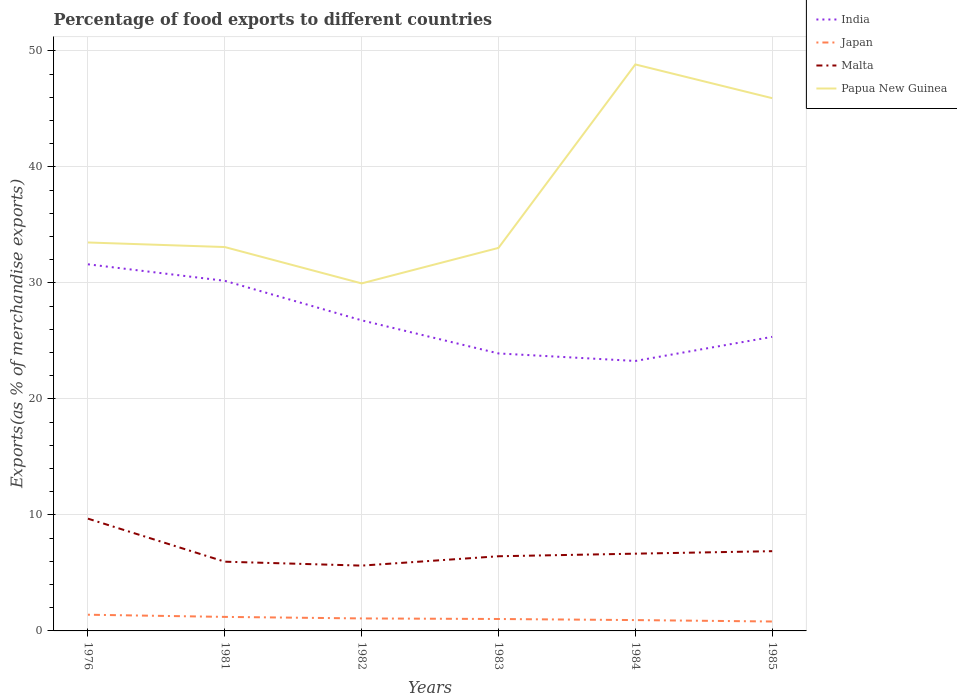How many different coloured lines are there?
Your response must be concise. 4. Is the number of lines equal to the number of legend labels?
Provide a succinct answer. Yes. Across all years, what is the maximum percentage of exports to different countries in India?
Give a very brief answer. 23.27. In which year was the percentage of exports to different countries in Malta maximum?
Keep it short and to the point. 1982. What is the total percentage of exports to different countries in Japan in the graph?
Provide a succinct answer. 0.4. What is the difference between the highest and the second highest percentage of exports to different countries in Japan?
Make the answer very short. 0.58. Does the graph contain any zero values?
Offer a very short reply. No. Does the graph contain grids?
Ensure brevity in your answer.  Yes. How are the legend labels stacked?
Provide a short and direct response. Vertical. What is the title of the graph?
Offer a terse response. Percentage of food exports to different countries. Does "France" appear as one of the legend labels in the graph?
Keep it short and to the point. No. What is the label or title of the X-axis?
Your response must be concise. Years. What is the label or title of the Y-axis?
Make the answer very short. Exports(as % of merchandise exports). What is the Exports(as % of merchandise exports) of India in 1976?
Your response must be concise. 31.6. What is the Exports(as % of merchandise exports) of Japan in 1976?
Your response must be concise. 1.4. What is the Exports(as % of merchandise exports) of Malta in 1976?
Offer a terse response. 9.68. What is the Exports(as % of merchandise exports) in Papua New Guinea in 1976?
Ensure brevity in your answer.  33.48. What is the Exports(as % of merchandise exports) in India in 1981?
Offer a terse response. 30.18. What is the Exports(as % of merchandise exports) of Japan in 1981?
Offer a terse response. 1.21. What is the Exports(as % of merchandise exports) in Malta in 1981?
Provide a short and direct response. 5.97. What is the Exports(as % of merchandise exports) in Papua New Guinea in 1981?
Your answer should be compact. 33.09. What is the Exports(as % of merchandise exports) in India in 1982?
Provide a succinct answer. 26.77. What is the Exports(as % of merchandise exports) in Japan in 1982?
Ensure brevity in your answer.  1.08. What is the Exports(as % of merchandise exports) in Malta in 1982?
Give a very brief answer. 5.63. What is the Exports(as % of merchandise exports) in Papua New Guinea in 1982?
Offer a terse response. 29.95. What is the Exports(as % of merchandise exports) in India in 1983?
Offer a very short reply. 23.92. What is the Exports(as % of merchandise exports) in Japan in 1983?
Provide a short and direct response. 1.03. What is the Exports(as % of merchandise exports) of Malta in 1983?
Provide a succinct answer. 6.44. What is the Exports(as % of merchandise exports) in Papua New Guinea in 1983?
Offer a terse response. 33.01. What is the Exports(as % of merchandise exports) of India in 1984?
Offer a terse response. 23.27. What is the Exports(as % of merchandise exports) of Japan in 1984?
Your response must be concise. 0.93. What is the Exports(as % of merchandise exports) in Malta in 1984?
Offer a very short reply. 6.66. What is the Exports(as % of merchandise exports) in Papua New Guinea in 1984?
Your response must be concise. 48.83. What is the Exports(as % of merchandise exports) of India in 1985?
Keep it short and to the point. 25.35. What is the Exports(as % of merchandise exports) of Japan in 1985?
Your answer should be very brief. 0.81. What is the Exports(as % of merchandise exports) of Malta in 1985?
Offer a terse response. 6.87. What is the Exports(as % of merchandise exports) in Papua New Guinea in 1985?
Ensure brevity in your answer.  45.92. Across all years, what is the maximum Exports(as % of merchandise exports) of India?
Give a very brief answer. 31.6. Across all years, what is the maximum Exports(as % of merchandise exports) in Japan?
Your answer should be compact. 1.4. Across all years, what is the maximum Exports(as % of merchandise exports) of Malta?
Your response must be concise. 9.68. Across all years, what is the maximum Exports(as % of merchandise exports) in Papua New Guinea?
Your answer should be very brief. 48.83. Across all years, what is the minimum Exports(as % of merchandise exports) of India?
Your answer should be very brief. 23.27. Across all years, what is the minimum Exports(as % of merchandise exports) in Japan?
Give a very brief answer. 0.81. Across all years, what is the minimum Exports(as % of merchandise exports) of Malta?
Keep it short and to the point. 5.63. Across all years, what is the minimum Exports(as % of merchandise exports) of Papua New Guinea?
Your response must be concise. 29.95. What is the total Exports(as % of merchandise exports) in India in the graph?
Make the answer very short. 161.08. What is the total Exports(as % of merchandise exports) of Japan in the graph?
Provide a succinct answer. 6.46. What is the total Exports(as % of merchandise exports) of Malta in the graph?
Keep it short and to the point. 41.24. What is the total Exports(as % of merchandise exports) in Papua New Guinea in the graph?
Provide a short and direct response. 224.28. What is the difference between the Exports(as % of merchandise exports) of India in 1976 and that in 1981?
Give a very brief answer. 1.42. What is the difference between the Exports(as % of merchandise exports) in Japan in 1976 and that in 1981?
Provide a short and direct response. 0.19. What is the difference between the Exports(as % of merchandise exports) in Malta in 1976 and that in 1981?
Ensure brevity in your answer.  3.71. What is the difference between the Exports(as % of merchandise exports) in Papua New Guinea in 1976 and that in 1981?
Provide a succinct answer. 0.39. What is the difference between the Exports(as % of merchandise exports) of India in 1976 and that in 1982?
Make the answer very short. 4.83. What is the difference between the Exports(as % of merchandise exports) in Japan in 1976 and that in 1982?
Your answer should be compact. 0.32. What is the difference between the Exports(as % of merchandise exports) of Malta in 1976 and that in 1982?
Make the answer very short. 4.05. What is the difference between the Exports(as % of merchandise exports) in Papua New Guinea in 1976 and that in 1982?
Provide a succinct answer. 3.53. What is the difference between the Exports(as % of merchandise exports) in India in 1976 and that in 1983?
Offer a very short reply. 7.68. What is the difference between the Exports(as % of merchandise exports) in Japan in 1976 and that in 1983?
Keep it short and to the point. 0.37. What is the difference between the Exports(as % of merchandise exports) in Malta in 1976 and that in 1983?
Your response must be concise. 3.24. What is the difference between the Exports(as % of merchandise exports) in Papua New Guinea in 1976 and that in 1983?
Offer a very short reply. 0.47. What is the difference between the Exports(as % of merchandise exports) of India in 1976 and that in 1984?
Your answer should be compact. 8.33. What is the difference between the Exports(as % of merchandise exports) in Japan in 1976 and that in 1984?
Keep it short and to the point. 0.46. What is the difference between the Exports(as % of merchandise exports) of Malta in 1976 and that in 1984?
Your response must be concise. 3.02. What is the difference between the Exports(as % of merchandise exports) in Papua New Guinea in 1976 and that in 1984?
Provide a short and direct response. -15.35. What is the difference between the Exports(as % of merchandise exports) of India in 1976 and that in 1985?
Offer a terse response. 6.25. What is the difference between the Exports(as % of merchandise exports) of Japan in 1976 and that in 1985?
Your answer should be compact. 0.58. What is the difference between the Exports(as % of merchandise exports) in Malta in 1976 and that in 1985?
Offer a very short reply. 2.8. What is the difference between the Exports(as % of merchandise exports) of Papua New Guinea in 1976 and that in 1985?
Your answer should be compact. -12.44. What is the difference between the Exports(as % of merchandise exports) of India in 1981 and that in 1982?
Ensure brevity in your answer.  3.41. What is the difference between the Exports(as % of merchandise exports) in Japan in 1981 and that in 1982?
Provide a succinct answer. 0.13. What is the difference between the Exports(as % of merchandise exports) of Malta in 1981 and that in 1982?
Offer a terse response. 0.34. What is the difference between the Exports(as % of merchandise exports) of Papua New Guinea in 1981 and that in 1982?
Give a very brief answer. 3.13. What is the difference between the Exports(as % of merchandise exports) in India in 1981 and that in 1983?
Ensure brevity in your answer.  6.26. What is the difference between the Exports(as % of merchandise exports) of Japan in 1981 and that in 1983?
Give a very brief answer. 0.18. What is the difference between the Exports(as % of merchandise exports) of Malta in 1981 and that in 1983?
Keep it short and to the point. -0.47. What is the difference between the Exports(as % of merchandise exports) in Papua New Guinea in 1981 and that in 1983?
Your answer should be compact. 0.07. What is the difference between the Exports(as % of merchandise exports) of India in 1981 and that in 1984?
Keep it short and to the point. 6.91. What is the difference between the Exports(as % of merchandise exports) of Japan in 1981 and that in 1984?
Make the answer very short. 0.27. What is the difference between the Exports(as % of merchandise exports) of Malta in 1981 and that in 1984?
Ensure brevity in your answer.  -0.69. What is the difference between the Exports(as % of merchandise exports) of Papua New Guinea in 1981 and that in 1984?
Keep it short and to the point. -15.74. What is the difference between the Exports(as % of merchandise exports) in India in 1981 and that in 1985?
Offer a very short reply. 4.83. What is the difference between the Exports(as % of merchandise exports) in Japan in 1981 and that in 1985?
Make the answer very short. 0.4. What is the difference between the Exports(as % of merchandise exports) in Malta in 1981 and that in 1985?
Offer a very short reply. -0.91. What is the difference between the Exports(as % of merchandise exports) of Papua New Guinea in 1981 and that in 1985?
Ensure brevity in your answer.  -12.83. What is the difference between the Exports(as % of merchandise exports) of India in 1982 and that in 1983?
Ensure brevity in your answer.  2.85. What is the difference between the Exports(as % of merchandise exports) in Japan in 1982 and that in 1983?
Provide a succinct answer. 0.05. What is the difference between the Exports(as % of merchandise exports) of Malta in 1982 and that in 1983?
Provide a short and direct response. -0.81. What is the difference between the Exports(as % of merchandise exports) of Papua New Guinea in 1982 and that in 1983?
Provide a short and direct response. -3.06. What is the difference between the Exports(as % of merchandise exports) of India in 1982 and that in 1984?
Make the answer very short. 3.5. What is the difference between the Exports(as % of merchandise exports) of Japan in 1982 and that in 1984?
Give a very brief answer. 0.14. What is the difference between the Exports(as % of merchandise exports) in Malta in 1982 and that in 1984?
Your answer should be very brief. -1.03. What is the difference between the Exports(as % of merchandise exports) in Papua New Guinea in 1982 and that in 1984?
Provide a succinct answer. -18.87. What is the difference between the Exports(as % of merchandise exports) in India in 1982 and that in 1985?
Offer a terse response. 1.43. What is the difference between the Exports(as % of merchandise exports) in Japan in 1982 and that in 1985?
Offer a very short reply. 0.26. What is the difference between the Exports(as % of merchandise exports) of Malta in 1982 and that in 1985?
Provide a short and direct response. -1.24. What is the difference between the Exports(as % of merchandise exports) in Papua New Guinea in 1982 and that in 1985?
Your answer should be very brief. -15.97. What is the difference between the Exports(as % of merchandise exports) of India in 1983 and that in 1984?
Give a very brief answer. 0.65. What is the difference between the Exports(as % of merchandise exports) of Japan in 1983 and that in 1984?
Give a very brief answer. 0.09. What is the difference between the Exports(as % of merchandise exports) of Malta in 1983 and that in 1984?
Offer a terse response. -0.22. What is the difference between the Exports(as % of merchandise exports) in Papua New Guinea in 1983 and that in 1984?
Offer a very short reply. -15.81. What is the difference between the Exports(as % of merchandise exports) in India in 1983 and that in 1985?
Make the answer very short. -1.43. What is the difference between the Exports(as % of merchandise exports) in Japan in 1983 and that in 1985?
Your answer should be very brief. 0.22. What is the difference between the Exports(as % of merchandise exports) of Malta in 1983 and that in 1985?
Offer a very short reply. -0.44. What is the difference between the Exports(as % of merchandise exports) of Papua New Guinea in 1983 and that in 1985?
Give a very brief answer. -12.9. What is the difference between the Exports(as % of merchandise exports) of India in 1984 and that in 1985?
Offer a terse response. -2.08. What is the difference between the Exports(as % of merchandise exports) in Japan in 1984 and that in 1985?
Keep it short and to the point. 0.12. What is the difference between the Exports(as % of merchandise exports) of Malta in 1984 and that in 1985?
Make the answer very short. -0.21. What is the difference between the Exports(as % of merchandise exports) in Papua New Guinea in 1984 and that in 1985?
Give a very brief answer. 2.91. What is the difference between the Exports(as % of merchandise exports) of India in 1976 and the Exports(as % of merchandise exports) of Japan in 1981?
Provide a short and direct response. 30.39. What is the difference between the Exports(as % of merchandise exports) in India in 1976 and the Exports(as % of merchandise exports) in Malta in 1981?
Offer a terse response. 25.63. What is the difference between the Exports(as % of merchandise exports) of India in 1976 and the Exports(as % of merchandise exports) of Papua New Guinea in 1981?
Ensure brevity in your answer.  -1.49. What is the difference between the Exports(as % of merchandise exports) in Japan in 1976 and the Exports(as % of merchandise exports) in Malta in 1981?
Offer a terse response. -4.57. What is the difference between the Exports(as % of merchandise exports) in Japan in 1976 and the Exports(as % of merchandise exports) in Papua New Guinea in 1981?
Your answer should be compact. -31.69. What is the difference between the Exports(as % of merchandise exports) in Malta in 1976 and the Exports(as % of merchandise exports) in Papua New Guinea in 1981?
Ensure brevity in your answer.  -23.41. What is the difference between the Exports(as % of merchandise exports) of India in 1976 and the Exports(as % of merchandise exports) of Japan in 1982?
Offer a terse response. 30.52. What is the difference between the Exports(as % of merchandise exports) in India in 1976 and the Exports(as % of merchandise exports) in Malta in 1982?
Your response must be concise. 25.97. What is the difference between the Exports(as % of merchandise exports) in India in 1976 and the Exports(as % of merchandise exports) in Papua New Guinea in 1982?
Provide a short and direct response. 1.65. What is the difference between the Exports(as % of merchandise exports) of Japan in 1976 and the Exports(as % of merchandise exports) of Malta in 1982?
Ensure brevity in your answer.  -4.23. What is the difference between the Exports(as % of merchandise exports) of Japan in 1976 and the Exports(as % of merchandise exports) of Papua New Guinea in 1982?
Offer a terse response. -28.55. What is the difference between the Exports(as % of merchandise exports) of Malta in 1976 and the Exports(as % of merchandise exports) of Papua New Guinea in 1982?
Your response must be concise. -20.27. What is the difference between the Exports(as % of merchandise exports) in India in 1976 and the Exports(as % of merchandise exports) in Japan in 1983?
Offer a very short reply. 30.57. What is the difference between the Exports(as % of merchandise exports) of India in 1976 and the Exports(as % of merchandise exports) of Malta in 1983?
Your answer should be compact. 25.16. What is the difference between the Exports(as % of merchandise exports) of India in 1976 and the Exports(as % of merchandise exports) of Papua New Guinea in 1983?
Offer a very short reply. -1.41. What is the difference between the Exports(as % of merchandise exports) of Japan in 1976 and the Exports(as % of merchandise exports) of Malta in 1983?
Make the answer very short. -5.04. What is the difference between the Exports(as % of merchandise exports) of Japan in 1976 and the Exports(as % of merchandise exports) of Papua New Guinea in 1983?
Keep it short and to the point. -31.62. What is the difference between the Exports(as % of merchandise exports) in Malta in 1976 and the Exports(as % of merchandise exports) in Papua New Guinea in 1983?
Offer a terse response. -23.34. What is the difference between the Exports(as % of merchandise exports) in India in 1976 and the Exports(as % of merchandise exports) in Japan in 1984?
Provide a short and direct response. 30.66. What is the difference between the Exports(as % of merchandise exports) in India in 1976 and the Exports(as % of merchandise exports) in Malta in 1984?
Provide a succinct answer. 24.94. What is the difference between the Exports(as % of merchandise exports) of India in 1976 and the Exports(as % of merchandise exports) of Papua New Guinea in 1984?
Provide a succinct answer. -17.23. What is the difference between the Exports(as % of merchandise exports) of Japan in 1976 and the Exports(as % of merchandise exports) of Malta in 1984?
Offer a very short reply. -5.26. What is the difference between the Exports(as % of merchandise exports) in Japan in 1976 and the Exports(as % of merchandise exports) in Papua New Guinea in 1984?
Your answer should be very brief. -47.43. What is the difference between the Exports(as % of merchandise exports) in Malta in 1976 and the Exports(as % of merchandise exports) in Papua New Guinea in 1984?
Offer a very short reply. -39.15. What is the difference between the Exports(as % of merchandise exports) of India in 1976 and the Exports(as % of merchandise exports) of Japan in 1985?
Keep it short and to the point. 30.79. What is the difference between the Exports(as % of merchandise exports) in India in 1976 and the Exports(as % of merchandise exports) in Malta in 1985?
Offer a terse response. 24.73. What is the difference between the Exports(as % of merchandise exports) in India in 1976 and the Exports(as % of merchandise exports) in Papua New Guinea in 1985?
Your response must be concise. -14.32. What is the difference between the Exports(as % of merchandise exports) of Japan in 1976 and the Exports(as % of merchandise exports) of Malta in 1985?
Your answer should be compact. -5.48. What is the difference between the Exports(as % of merchandise exports) in Japan in 1976 and the Exports(as % of merchandise exports) in Papua New Guinea in 1985?
Provide a short and direct response. -44.52. What is the difference between the Exports(as % of merchandise exports) in Malta in 1976 and the Exports(as % of merchandise exports) in Papua New Guinea in 1985?
Your answer should be very brief. -36.24. What is the difference between the Exports(as % of merchandise exports) in India in 1981 and the Exports(as % of merchandise exports) in Japan in 1982?
Your response must be concise. 29.1. What is the difference between the Exports(as % of merchandise exports) in India in 1981 and the Exports(as % of merchandise exports) in Malta in 1982?
Offer a terse response. 24.55. What is the difference between the Exports(as % of merchandise exports) of India in 1981 and the Exports(as % of merchandise exports) of Papua New Guinea in 1982?
Give a very brief answer. 0.23. What is the difference between the Exports(as % of merchandise exports) of Japan in 1981 and the Exports(as % of merchandise exports) of Malta in 1982?
Give a very brief answer. -4.42. What is the difference between the Exports(as % of merchandise exports) of Japan in 1981 and the Exports(as % of merchandise exports) of Papua New Guinea in 1982?
Offer a terse response. -28.74. What is the difference between the Exports(as % of merchandise exports) of Malta in 1981 and the Exports(as % of merchandise exports) of Papua New Guinea in 1982?
Provide a succinct answer. -23.98. What is the difference between the Exports(as % of merchandise exports) of India in 1981 and the Exports(as % of merchandise exports) of Japan in 1983?
Your answer should be very brief. 29.15. What is the difference between the Exports(as % of merchandise exports) of India in 1981 and the Exports(as % of merchandise exports) of Malta in 1983?
Provide a succinct answer. 23.74. What is the difference between the Exports(as % of merchandise exports) in India in 1981 and the Exports(as % of merchandise exports) in Papua New Guinea in 1983?
Provide a short and direct response. -2.84. What is the difference between the Exports(as % of merchandise exports) of Japan in 1981 and the Exports(as % of merchandise exports) of Malta in 1983?
Keep it short and to the point. -5.23. What is the difference between the Exports(as % of merchandise exports) of Japan in 1981 and the Exports(as % of merchandise exports) of Papua New Guinea in 1983?
Ensure brevity in your answer.  -31.8. What is the difference between the Exports(as % of merchandise exports) of Malta in 1981 and the Exports(as % of merchandise exports) of Papua New Guinea in 1983?
Your answer should be very brief. -27.05. What is the difference between the Exports(as % of merchandise exports) of India in 1981 and the Exports(as % of merchandise exports) of Japan in 1984?
Provide a short and direct response. 29.24. What is the difference between the Exports(as % of merchandise exports) of India in 1981 and the Exports(as % of merchandise exports) of Malta in 1984?
Your answer should be compact. 23.52. What is the difference between the Exports(as % of merchandise exports) of India in 1981 and the Exports(as % of merchandise exports) of Papua New Guinea in 1984?
Your answer should be very brief. -18.65. What is the difference between the Exports(as % of merchandise exports) of Japan in 1981 and the Exports(as % of merchandise exports) of Malta in 1984?
Your response must be concise. -5.45. What is the difference between the Exports(as % of merchandise exports) in Japan in 1981 and the Exports(as % of merchandise exports) in Papua New Guinea in 1984?
Give a very brief answer. -47.62. What is the difference between the Exports(as % of merchandise exports) in Malta in 1981 and the Exports(as % of merchandise exports) in Papua New Guinea in 1984?
Your answer should be compact. -42.86. What is the difference between the Exports(as % of merchandise exports) of India in 1981 and the Exports(as % of merchandise exports) of Japan in 1985?
Keep it short and to the point. 29.37. What is the difference between the Exports(as % of merchandise exports) of India in 1981 and the Exports(as % of merchandise exports) of Malta in 1985?
Keep it short and to the point. 23.3. What is the difference between the Exports(as % of merchandise exports) in India in 1981 and the Exports(as % of merchandise exports) in Papua New Guinea in 1985?
Give a very brief answer. -15.74. What is the difference between the Exports(as % of merchandise exports) of Japan in 1981 and the Exports(as % of merchandise exports) of Malta in 1985?
Provide a short and direct response. -5.66. What is the difference between the Exports(as % of merchandise exports) of Japan in 1981 and the Exports(as % of merchandise exports) of Papua New Guinea in 1985?
Your answer should be very brief. -44.71. What is the difference between the Exports(as % of merchandise exports) in Malta in 1981 and the Exports(as % of merchandise exports) in Papua New Guinea in 1985?
Your answer should be compact. -39.95. What is the difference between the Exports(as % of merchandise exports) of India in 1982 and the Exports(as % of merchandise exports) of Japan in 1983?
Your answer should be very brief. 25.74. What is the difference between the Exports(as % of merchandise exports) of India in 1982 and the Exports(as % of merchandise exports) of Malta in 1983?
Provide a succinct answer. 20.34. What is the difference between the Exports(as % of merchandise exports) in India in 1982 and the Exports(as % of merchandise exports) in Papua New Guinea in 1983?
Provide a short and direct response. -6.24. What is the difference between the Exports(as % of merchandise exports) of Japan in 1982 and the Exports(as % of merchandise exports) of Malta in 1983?
Make the answer very short. -5.36. What is the difference between the Exports(as % of merchandise exports) in Japan in 1982 and the Exports(as % of merchandise exports) in Papua New Guinea in 1983?
Give a very brief answer. -31.94. What is the difference between the Exports(as % of merchandise exports) in Malta in 1982 and the Exports(as % of merchandise exports) in Papua New Guinea in 1983?
Your response must be concise. -27.38. What is the difference between the Exports(as % of merchandise exports) of India in 1982 and the Exports(as % of merchandise exports) of Japan in 1984?
Make the answer very short. 25.84. What is the difference between the Exports(as % of merchandise exports) in India in 1982 and the Exports(as % of merchandise exports) in Malta in 1984?
Your answer should be very brief. 20.11. What is the difference between the Exports(as % of merchandise exports) of India in 1982 and the Exports(as % of merchandise exports) of Papua New Guinea in 1984?
Offer a terse response. -22.06. What is the difference between the Exports(as % of merchandise exports) of Japan in 1982 and the Exports(as % of merchandise exports) of Malta in 1984?
Your response must be concise. -5.58. What is the difference between the Exports(as % of merchandise exports) in Japan in 1982 and the Exports(as % of merchandise exports) in Papua New Guinea in 1984?
Make the answer very short. -47.75. What is the difference between the Exports(as % of merchandise exports) of Malta in 1982 and the Exports(as % of merchandise exports) of Papua New Guinea in 1984?
Your answer should be very brief. -43.2. What is the difference between the Exports(as % of merchandise exports) in India in 1982 and the Exports(as % of merchandise exports) in Japan in 1985?
Offer a very short reply. 25.96. What is the difference between the Exports(as % of merchandise exports) of India in 1982 and the Exports(as % of merchandise exports) of Malta in 1985?
Ensure brevity in your answer.  19.9. What is the difference between the Exports(as % of merchandise exports) of India in 1982 and the Exports(as % of merchandise exports) of Papua New Guinea in 1985?
Provide a succinct answer. -19.15. What is the difference between the Exports(as % of merchandise exports) in Japan in 1982 and the Exports(as % of merchandise exports) in Malta in 1985?
Keep it short and to the point. -5.8. What is the difference between the Exports(as % of merchandise exports) in Japan in 1982 and the Exports(as % of merchandise exports) in Papua New Guinea in 1985?
Offer a very short reply. -44.84. What is the difference between the Exports(as % of merchandise exports) in Malta in 1982 and the Exports(as % of merchandise exports) in Papua New Guinea in 1985?
Give a very brief answer. -40.29. What is the difference between the Exports(as % of merchandise exports) in India in 1983 and the Exports(as % of merchandise exports) in Japan in 1984?
Provide a succinct answer. 22.98. What is the difference between the Exports(as % of merchandise exports) of India in 1983 and the Exports(as % of merchandise exports) of Malta in 1984?
Give a very brief answer. 17.26. What is the difference between the Exports(as % of merchandise exports) in India in 1983 and the Exports(as % of merchandise exports) in Papua New Guinea in 1984?
Keep it short and to the point. -24.91. What is the difference between the Exports(as % of merchandise exports) in Japan in 1983 and the Exports(as % of merchandise exports) in Malta in 1984?
Give a very brief answer. -5.63. What is the difference between the Exports(as % of merchandise exports) in Japan in 1983 and the Exports(as % of merchandise exports) in Papua New Guinea in 1984?
Provide a succinct answer. -47.8. What is the difference between the Exports(as % of merchandise exports) in Malta in 1983 and the Exports(as % of merchandise exports) in Papua New Guinea in 1984?
Your answer should be very brief. -42.39. What is the difference between the Exports(as % of merchandise exports) of India in 1983 and the Exports(as % of merchandise exports) of Japan in 1985?
Keep it short and to the point. 23.1. What is the difference between the Exports(as % of merchandise exports) in India in 1983 and the Exports(as % of merchandise exports) in Malta in 1985?
Your answer should be compact. 17.04. What is the difference between the Exports(as % of merchandise exports) in India in 1983 and the Exports(as % of merchandise exports) in Papua New Guinea in 1985?
Make the answer very short. -22. What is the difference between the Exports(as % of merchandise exports) in Japan in 1983 and the Exports(as % of merchandise exports) in Malta in 1985?
Give a very brief answer. -5.85. What is the difference between the Exports(as % of merchandise exports) of Japan in 1983 and the Exports(as % of merchandise exports) of Papua New Guinea in 1985?
Your response must be concise. -44.89. What is the difference between the Exports(as % of merchandise exports) in Malta in 1983 and the Exports(as % of merchandise exports) in Papua New Guinea in 1985?
Give a very brief answer. -39.48. What is the difference between the Exports(as % of merchandise exports) in India in 1984 and the Exports(as % of merchandise exports) in Japan in 1985?
Offer a terse response. 22.46. What is the difference between the Exports(as % of merchandise exports) of India in 1984 and the Exports(as % of merchandise exports) of Malta in 1985?
Your response must be concise. 16.39. What is the difference between the Exports(as % of merchandise exports) in India in 1984 and the Exports(as % of merchandise exports) in Papua New Guinea in 1985?
Your answer should be very brief. -22.65. What is the difference between the Exports(as % of merchandise exports) in Japan in 1984 and the Exports(as % of merchandise exports) in Malta in 1985?
Ensure brevity in your answer.  -5.94. What is the difference between the Exports(as % of merchandise exports) in Japan in 1984 and the Exports(as % of merchandise exports) in Papua New Guinea in 1985?
Keep it short and to the point. -44.98. What is the difference between the Exports(as % of merchandise exports) of Malta in 1984 and the Exports(as % of merchandise exports) of Papua New Guinea in 1985?
Keep it short and to the point. -39.26. What is the average Exports(as % of merchandise exports) of India per year?
Your answer should be very brief. 26.85. What is the average Exports(as % of merchandise exports) of Japan per year?
Make the answer very short. 1.08. What is the average Exports(as % of merchandise exports) of Malta per year?
Provide a short and direct response. 6.87. What is the average Exports(as % of merchandise exports) in Papua New Guinea per year?
Keep it short and to the point. 37.38. In the year 1976, what is the difference between the Exports(as % of merchandise exports) in India and Exports(as % of merchandise exports) in Japan?
Ensure brevity in your answer.  30.2. In the year 1976, what is the difference between the Exports(as % of merchandise exports) in India and Exports(as % of merchandise exports) in Malta?
Your answer should be compact. 21.92. In the year 1976, what is the difference between the Exports(as % of merchandise exports) of India and Exports(as % of merchandise exports) of Papua New Guinea?
Offer a very short reply. -1.88. In the year 1976, what is the difference between the Exports(as % of merchandise exports) of Japan and Exports(as % of merchandise exports) of Malta?
Offer a terse response. -8.28. In the year 1976, what is the difference between the Exports(as % of merchandise exports) of Japan and Exports(as % of merchandise exports) of Papua New Guinea?
Make the answer very short. -32.08. In the year 1976, what is the difference between the Exports(as % of merchandise exports) in Malta and Exports(as % of merchandise exports) in Papua New Guinea?
Provide a succinct answer. -23.8. In the year 1981, what is the difference between the Exports(as % of merchandise exports) of India and Exports(as % of merchandise exports) of Japan?
Provide a short and direct response. 28.97. In the year 1981, what is the difference between the Exports(as % of merchandise exports) in India and Exports(as % of merchandise exports) in Malta?
Keep it short and to the point. 24.21. In the year 1981, what is the difference between the Exports(as % of merchandise exports) in India and Exports(as % of merchandise exports) in Papua New Guinea?
Offer a terse response. -2.91. In the year 1981, what is the difference between the Exports(as % of merchandise exports) in Japan and Exports(as % of merchandise exports) in Malta?
Your answer should be compact. -4.76. In the year 1981, what is the difference between the Exports(as % of merchandise exports) in Japan and Exports(as % of merchandise exports) in Papua New Guinea?
Provide a short and direct response. -31.88. In the year 1981, what is the difference between the Exports(as % of merchandise exports) in Malta and Exports(as % of merchandise exports) in Papua New Guinea?
Your answer should be compact. -27.12. In the year 1982, what is the difference between the Exports(as % of merchandise exports) in India and Exports(as % of merchandise exports) in Japan?
Keep it short and to the point. 25.69. In the year 1982, what is the difference between the Exports(as % of merchandise exports) in India and Exports(as % of merchandise exports) in Malta?
Provide a succinct answer. 21.14. In the year 1982, what is the difference between the Exports(as % of merchandise exports) of India and Exports(as % of merchandise exports) of Papua New Guinea?
Your response must be concise. -3.18. In the year 1982, what is the difference between the Exports(as % of merchandise exports) in Japan and Exports(as % of merchandise exports) in Malta?
Your response must be concise. -4.55. In the year 1982, what is the difference between the Exports(as % of merchandise exports) of Japan and Exports(as % of merchandise exports) of Papua New Guinea?
Ensure brevity in your answer.  -28.88. In the year 1982, what is the difference between the Exports(as % of merchandise exports) of Malta and Exports(as % of merchandise exports) of Papua New Guinea?
Ensure brevity in your answer.  -24.32. In the year 1983, what is the difference between the Exports(as % of merchandise exports) in India and Exports(as % of merchandise exports) in Japan?
Keep it short and to the point. 22.89. In the year 1983, what is the difference between the Exports(as % of merchandise exports) of India and Exports(as % of merchandise exports) of Malta?
Your answer should be very brief. 17.48. In the year 1983, what is the difference between the Exports(as % of merchandise exports) of India and Exports(as % of merchandise exports) of Papua New Guinea?
Offer a very short reply. -9.1. In the year 1983, what is the difference between the Exports(as % of merchandise exports) of Japan and Exports(as % of merchandise exports) of Malta?
Keep it short and to the point. -5.41. In the year 1983, what is the difference between the Exports(as % of merchandise exports) of Japan and Exports(as % of merchandise exports) of Papua New Guinea?
Your response must be concise. -31.98. In the year 1983, what is the difference between the Exports(as % of merchandise exports) of Malta and Exports(as % of merchandise exports) of Papua New Guinea?
Your answer should be compact. -26.58. In the year 1984, what is the difference between the Exports(as % of merchandise exports) in India and Exports(as % of merchandise exports) in Japan?
Your answer should be compact. 22.33. In the year 1984, what is the difference between the Exports(as % of merchandise exports) of India and Exports(as % of merchandise exports) of Malta?
Give a very brief answer. 16.61. In the year 1984, what is the difference between the Exports(as % of merchandise exports) of India and Exports(as % of merchandise exports) of Papua New Guinea?
Your response must be concise. -25.56. In the year 1984, what is the difference between the Exports(as % of merchandise exports) in Japan and Exports(as % of merchandise exports) in Malta?
Make the answer very short. -5.72. In the year 1984, what is the difference between the Exports(as % of merchandise exports) in Japan and Exports(as % of merchandise exports) in Papua New Guinea?
Give a very brief answer. -47.89. In the year 1984, what is the difference between the Exports(as % of merchandise exports) of Malta and Exports(as % of merchandise exports) of Papua New Guinea?
Offer a terse response. -42.17. In the year 1985, what is the difference between the Exports(as % of merchandise exports) in India and Exports(as % of merchandise exports) in Japan?
Make the answer very short. 24.53. In the year 1985, what is the difference between the Exports(as % of merchandise exports) of India and Exports(as % of merchandise exports) of Malta?
Keep it short and to the point. 18.47. In the year 1985, what is the difference between the Exports(as % of merchandise exports) of India and Exports(as % of merchandise exports) of Papua New Guinea?
Provide a short and direct response. -20.57. In the year 1985, what is the difference between the Exports(as % of merchandise exports) of Japan and Exports(as % of merchandise exports) of Malta?
Keep it short and to the point. -6.06. In the year 1985, what is the difference between the Exports(as % of merchandise exports) in Japan and Exports(as % of merchandise exports) in Papua New Guinea?
Give a very brief answer. -45.11. In the year 1985, what is the difference between the Exports(as % of merchandise exports) of Malta and Exports(as % of merchandise exports) of Papua New Guinea?
Ensure brevity in your answer.  -39.04. What is the ratio of the Exports(as % of merchandise exports) of India in 1976 to that in 1981?
Make the answer very short. 1.05. What is the ratio of the Exports(as % of merchandise exports) of Japan in 1976 to that in 1981?
Give a very brief answer. 1.16. What is the ratio of the Exports(as % of merchandise exports) of Malta in 1976 to that in 1981?
Offer a terse response. 1.62. What is the ratio of the Exports(as % of merchandise exports) in Papua New Guinea in 1976 to that in 1981?
Your answer should be very brief. 1.01. What is the ratio of the Exports(as % of merchandise exports) of India in 1976 to that in 1982?
Your answer should be compact. 1.18. What is the ratio of the Exports(as % of merchandise exports) in Japan in 1976 to that in 1982?
Your answer should be compact. 1.3. What is the ratio of the Exports(as % of merchandise exports) of Malta in 1976 to that in 1982?
Provide a succinct answer. 1.72. What is the ratio of the Exports(as % of merchandise exports) of Papua New Guinea in 1976 to that in 1982?
Provide a short and direct response. 1.12. What is the ratio of the Exports(as % of merchandise exports) in India in 1976 to that in 1983?
Give a very brief answer. 1.32. What is the ratio of the Exports(as % of merchandise exports) in Japan in 1976 to that in 1983?
Give a very brief answer. 1.36. What is the ratio of the Exports(as % of merchandise exports) in Malta in 1976 to that in 1983?
Your answer should be very brief. 1.5. What is the ratio of the Exports(as % of merchandise exports) of Papua New Guinea in 1976 to that in 1983?
Your answer should be compact. 1.01. What is the ratio of the Exports(as % of merchandise exports) of India in 1976 to that in 1984?
Offer a terse response. 1.36. What is the ratio of the Exports(as % of merchandise exports) in Japan in 1976 to that in 1984?
Ensure brevity in your answer.  1.5. What is the ratio of the Exports(as % of merchandise exports) in Malta in 1976 to that in 1984?
Offer a terse response. 1.45. What is the ratio of the Exports(as % of merchandise exports) in Papua New Guinea in 1976 to that in 1984?
Offer a terse response. 0.69. What is the ratio of the Exports(as % of merchandise exports) in India in 1976 to that in 1985?
Make the answer very short. 1.25. What is the ratio of the Exports(as % of merchandise exports) in Japan in 1976 to that in 1985?
Your answer should be very brief. 1.72. What is the ratio of the Exports(as % of merchandise exports) of Malta in 1976 to that in 1985?
Provide a short and direct response. 1.41. What is the ratio of the Exports(as % of merchandise exports) of Papua New Guinea in 1976 to that in 1985?
Give a very brief answer. 0.73. What is the ratio of the Exports(as % of merchandise exports) in India in 1981 to that in 1982?
Offer a very short reply. 1.13. What is the ratio of the Exports(as % of merchandise exports) of Japan in 1981 to that in 1982?
Give a very brief answer. 1.12. What is the ratio of the Exports(as % of merchandise exports) in Malta in 1981 to that in 1982?
Give a very brief answer. 1.06. What is the ratio of the Exports(as % of merchandise exports) in Papua New Guinea in 1981 to that in 1982?
Keep it short and to the point. 1.1. What is the ratio of the Exports(as % of merchandise exports) of India in 1981 to that in 1983?
Make the answer very short. 1.26. What is the ratio of the Exports(as % of merchandise exports) of Japan in 1981 to that in 1983?
Your answer should be compact. 1.18. What is the ratio of the Exports(as % of merchandise exports) of Malta in 1981 to that in 1983?
Provide a succinct answer. 0.93. What is the ratio of the Exports(as % of merchandise exports) in Papua New Guinea in 1981 to that in 1983?
Your answer should be compact. 1. What is the ratio of the Exports(as % of merchandise exports) of India in 1981 to that in 1984?
Your answer should be compact. 1.3. What is the ratio of the Exports(as % of merchandise exports) in Japan in 1981 to that in 1984?
Make the answer very short. 1.29. What is the ratio of the Exports(as % of merchandise exports) in Malta in 1981 to that in 1984?
Your answer should be compact. 0.9. What is the ratio of the Exports(as % of merchandise exports) of Papua New Guinea in 1981 to that in 1984?
Provide a succinct answer. 0.68. What is the ratio of the Exports(as % of merchandise exports) in India in 1981 to that in 1985?
Your answer should be very brief. 1.19. What is the ratio of the Exports(as % of merchandise exports) in Japan in 1981 to that in 1985?
Ensure brevity in your answer.  1.49. What is the ratio of the Exports(as % of merchandise exports) of Malta in 1981 to that in 1985?
Offer a terse response. 0.87. What is the ratio of the Exports(as % of merchandise exports) of Papua New Guinea in 1981 to that in 1985?
Give a very brief answer. 0.72. What is the ratio of the Exports(as % of merchandise exports) in India in 1982 to that in 1983?
Your response must be concise. 1.12. What is the ratio of the Exports(as % of merchandise exports) in Japan in 1982 to that in 1983?
Provide a succinct answer. 1.05. What is the ratio of the Exports(as % of merchandise exports) in Malta in 1982 to that in 1983?
Your answer should be compact. 0.87. What is the ratio of the Exports(as % of merchandise exports) in Papua New Guinea in 1982 to that in 1983?
Keep it short and to the point. 0.91. What is the ratio of the Exports(as % of merchandise exports) of India in 1982 to that in 1984?
Offer a terse response. 1.15. What is the ratio of the Exports(as % of merchandise exports) in Japan in 1982 to that in 1984?
Keep it short and to the point. 1.15. What is the ratio of the Exports(as % of merchandise exports) in Malta in 1982 to that in 1984?
Make the answer very short. 0.85. What is the ratio of the Exports(as % of merchandise exports) in Papua New Guinea in 1982 to that in 1984?
Offer a very short reply. 0.61. What is the ratio of the Exports(as % of merchandise exports) in India in 1982 to that in 1985?
Keep it short and to the point. 1.06. What is the ratio of the Exports(as % of merchandise exports) of Japan in 1982 to that in 1985?
Offer a terse response. 1.33. What is the ratio of the Exports(as % of merchandise exports) of Malta in 1982 to that in 1985?
Your answer should be very brief. 0.82. What is the ratio of the Exports(as % of merchandise exports) in Papua New Guinea in 1982 to that in 1985?
Your response must be concise. 0.65. What is the ratio of the Exports(as % of merchandise exports) of India in 1983 to that in 1984?
Your answer should be compact. 1.03. What is the ratio of the Exports(as % of merchandise exports) of Japan in 1983 to that in 1984?
Provide a short and direct response. 1.1. What is the ratio of the Exports(as % of merchandise exports) of Malta in 1983 to that in 1984?
Keep it short and to the point. 0.97. What is the ratio of the Exports(as % of merchandise exports) in Papua New Guinea in 1983 to that in 1984?
Your answer should be very brief. 0.68. What is the ratio of the Exports(as % of merchandise exports) in India in 1983 to that in 1985?
Your response must be concise. 0.94. What is the ratio of the Exports(as % of merchandise exports) of Japan in 1983 to that in 1985?
Your response must be concise. 1.27. What is the ratio of the Exports(as % of merchandise exports) of Malta in 1983 to that in 1985?
Provide a short and direct response. 0.94. What is the ratio of the Exports(as % of merchandise exports) in Papua New Guinea in 1983 to that in 1985?
Offer a very short reply. 0.72. What is the ratio of the Exports(as % of merchandise exports) of India in 1984 to that in 1985?
Keep it short and to the point. 0.92. What is the ratio of the Exports(as % of merchandise exports) in Japan in 1984 to that in 1985?
Make the answer very short. 1.15. What is the ratio of the Exports(as % of merchandise exports) of Malta in 1984 to that in 1985?
Make the answer very short. 0.97. What is the ratio of the Exports(as % of merchandise exports) in Papua New Guinea in 1984 to that in 1985?
Your response must be concise. 1.06. What is the difference between the highest and the second highest Exports(as % of merchandise exports) of India?
Give a very brief answer. 1.42. What is the difference between the highest and the second highest Exports(as % of merchandise exports) in Japan?
Make the answer very short. 0.19. What is the difference between the highest and the second highest Exports(as % of merchandise exports) of Malta?
Your answer should be very brief. 2.8. What is the difference between the highest and the second highest Exports(as % of merchandise exports) in Papua New Guinea?
Your answer should be very brief. 2.91. What is the difference between the highest and the lowest Exports(as % of merchandise exports) in India?
Offer a very short reply. 8.33. What is the difference between the highest and the lowest Exports(as % of merchandise exports) of Japan?
Your answer should be very brief. 0.58. What is the difference between the highest and the lowest Exports(as % of merchandise exports) of Malta?
Provide a succinct answer. 4.05. What is the difference between the highest and the lowest Exports(as % of merchandise exports) in Papua New Guinea?
Ensure brevity in your answer.  18.87. 